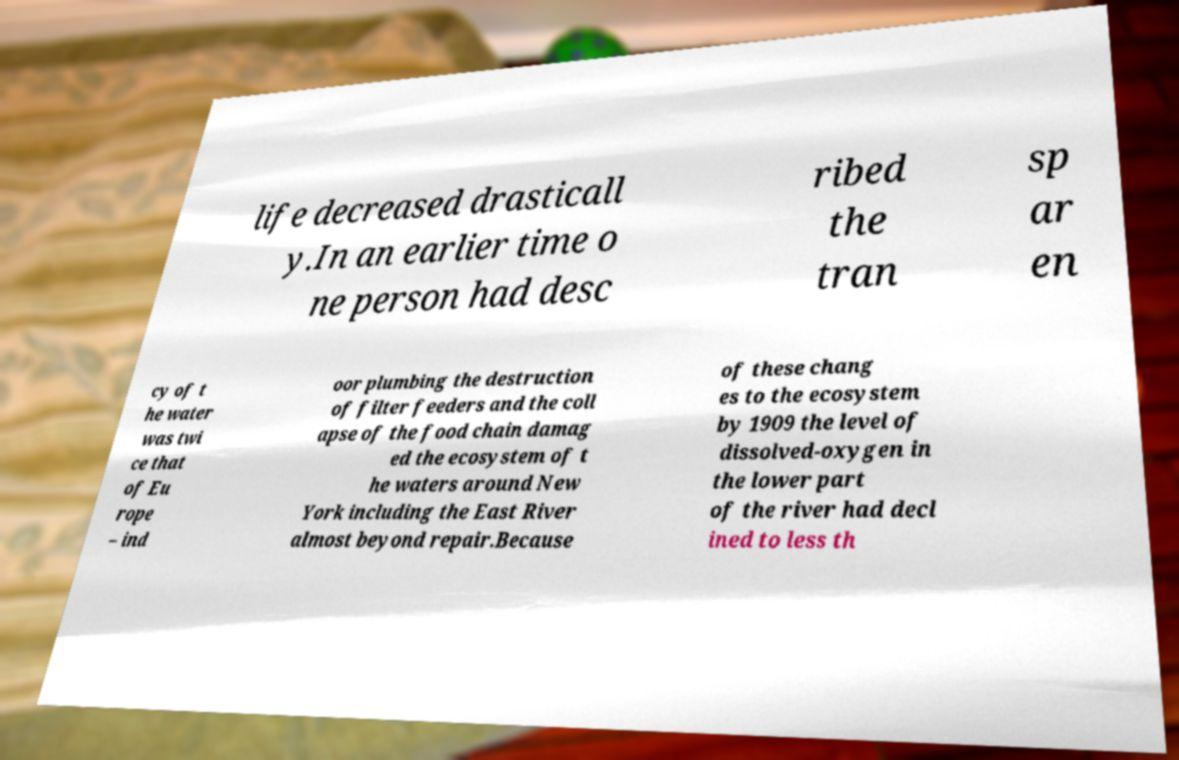Can you read and provide the text displayed in the image?This photo seems to have some interesting text. Can you extract and type it out for me? life decreased drasticall y.In an earlier time o ne person had desc ribed the tran sp ar en cy of t he water was twi ce that of Eu rope – ind oor plumbing the destruction of filter feeders and the coll apse of the food chain damag ed the ecosystem of t he waters around New York including the East River almost beyond repair.Because of these chang es to the ecosystem by 1909 the level of dissolved-oxygen in the lower part of the river had decl ined to less th 